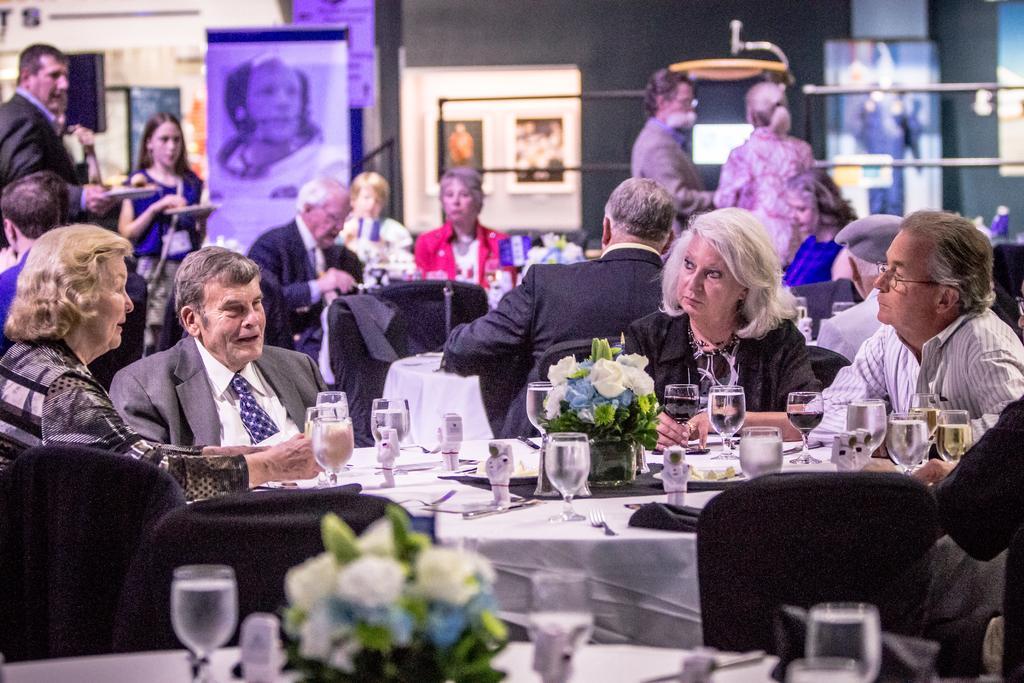How would you summarize this image in a sentence or two? There are group of people sitting on the chair around a table and few are standing in the background. We can also see posters,hoardings,pole and wall. On the table there are glasses,flower vase. 